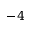Convert formula to latex. <formula><loc_0><loc_0><loc_500><loc_500>- 4</formula> 